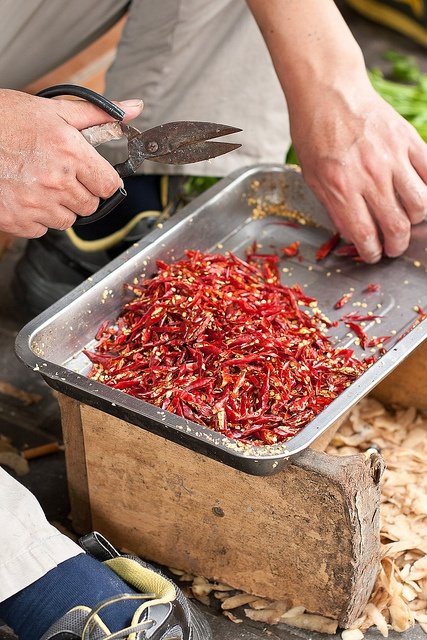Describe the objects in this image and their specific colors. I can see people in darkgray, lightpink, lightgray, black, and gray tones, people in darkgray, lightpink, lightgray, brown, and tan tones, and scissors in darkgray, gray, lightpink, and maroon tones in this image. 